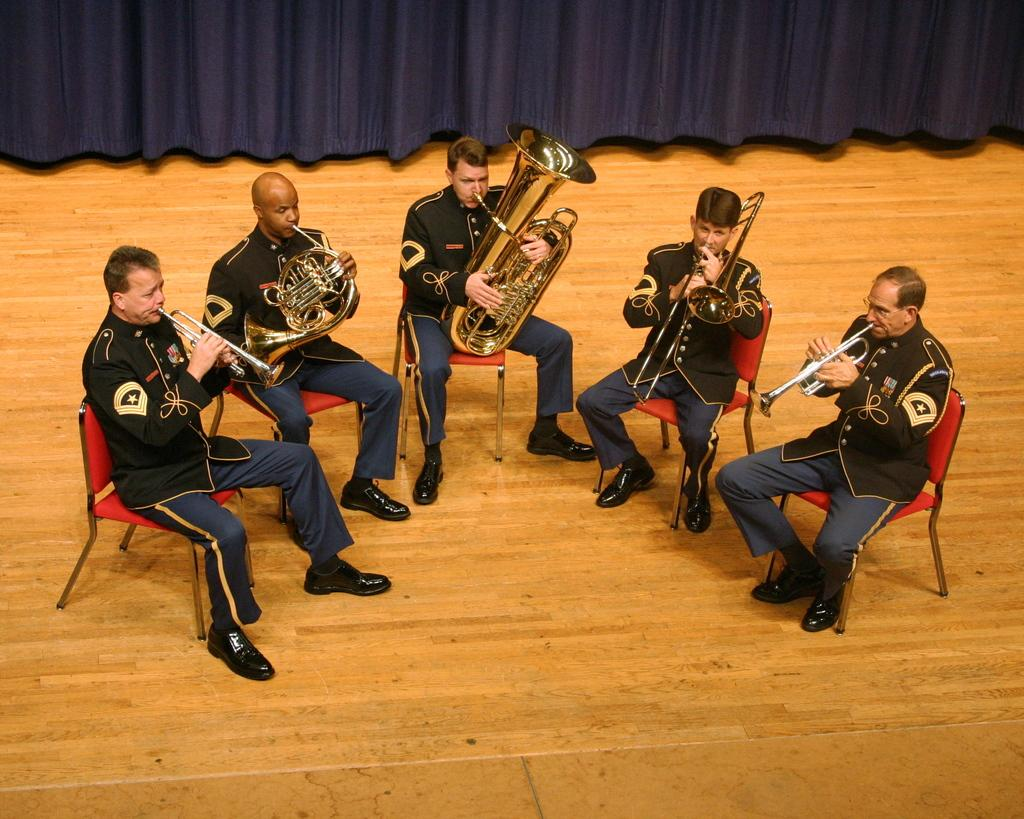What is happening in the image involving a group of people? There is a group of people in the image, and they are playing musical instruments. How are the people positioned in the image? The people are sitting on chairs in the image. What are the people wearing in the image? The people are wearing the same type of dress in the image. What else can be seen in the image besides the people? There is a curtain visible at the top of the image. What type of oatmeal is being served to the tiger in the image? There is no tiger or oatmeal present in the image. How is the group of people measuring the sound of their instruments in the image? The image does not show any measuring of sound; the people are simply playing their instruments. 